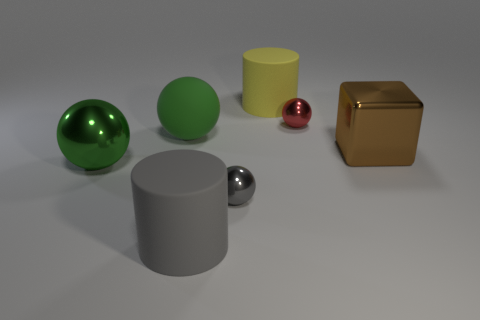How many large brown blocks are right of the gray sphere?
Offer a very short reply. 1. There is a cylinder that is in front of the big metal cube that is right of the large green object in front of the brown shiny cube; what color is it?
Your answer should be very brief. Gray. Is the color of the shiny ball behind the green shiny ball the same as the rubber object in front of the large brown metal object?
Provide a succinct answer. No. There is a small shiny object right of the tiny thing that is left of the yellow object; what shape is it?
Offer a terse response. Sphere. Are there any green shiny spheres of the same size as the gray sphere?
Offer a very short reply. No. How many other big shiny things have the same shape as the large gray object?
Offer a terse response. 0. Is the number of brown objects that are on the left side of the tiny red shiny thing the same as the number of large metallic blocks behind the large matte ball?
Make the answer very short. Yes. Are there any yellow rubber cylinders?
Provide a succinct answer. Yes. What size is the rubber cylinder to the right of the big cylinder that is left of the big matte cylinder that is behind the tiny gray metallic sphere?
Ensure brevity in your answer.  Large. There is a red metallic thing that is the same size as the gray metallic sphere; what shape is it?
Offer a very short reply. Sphere. 